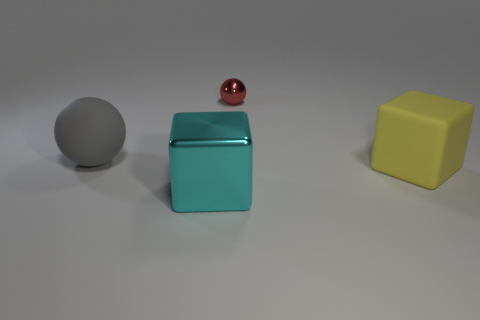Subtract all yellow cubes. How many cubes are left? 1 Add 4 metallic blocks. How many objects exist? 8 Add 3 large things. How many large things are left? 6 Add 1 yellow rubber things. How many yellow rubber things exist? 2 Subtract 0 brown spheres. How many objects are left? 4 Subtract 2 spheres. How many spheres are left? 0 Subtract all cyan spheres. Subtract all purple cylinders. How many spheres are left? 2 Subtract all yellow spheres. How many purple cubes are left? 0 Subtract all red things. Subtract all cyan rubber cylinders. How many objects are left? 3 